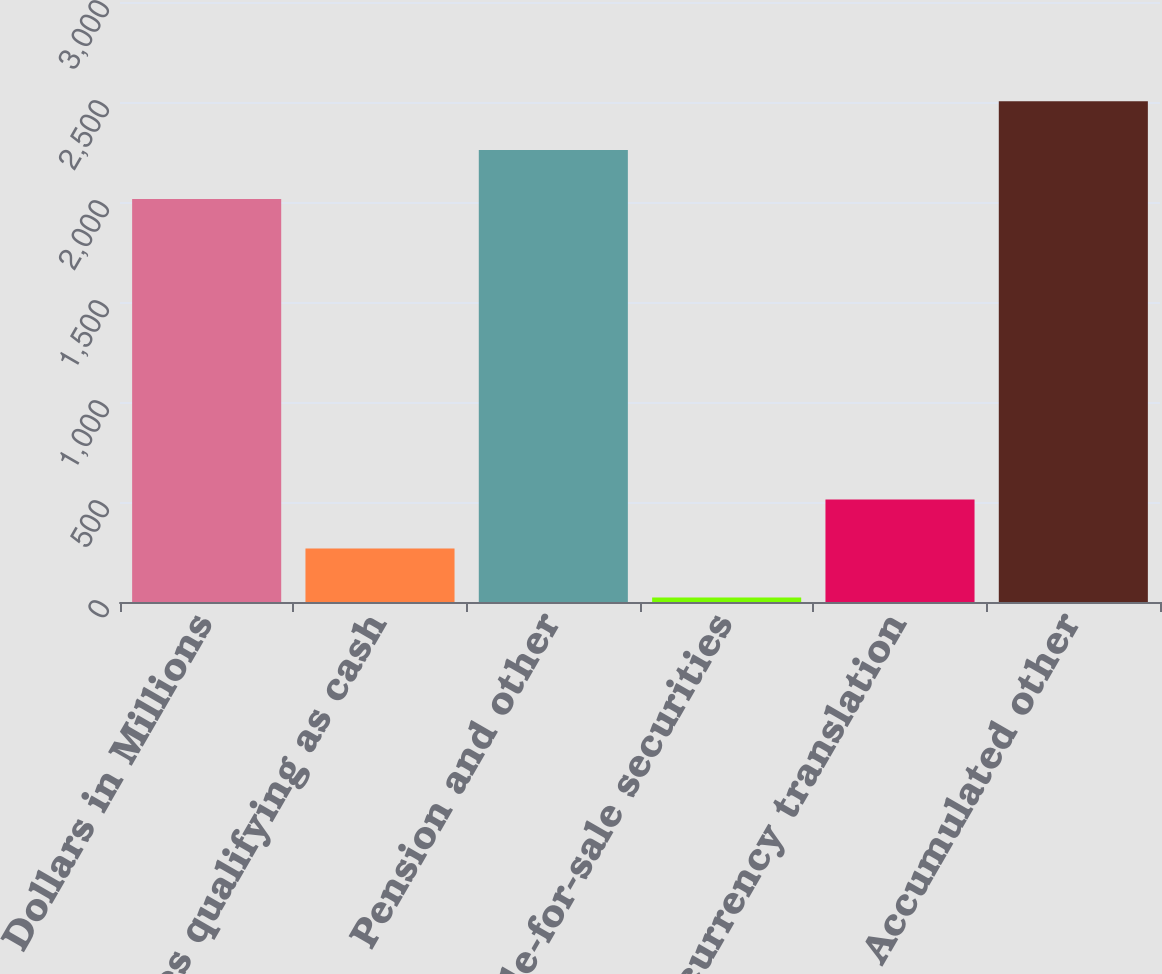<chart> <loc_0><loc_0><loc_500><loc_500><bar_chart><fcel>Dollars in Millions<fcel>Derivatives qualifying as cash<fcel>Pension and other<fcel>Available-for-sale securities<fcel>Foreign currency translation<fcel>Accumulated other<nl><fcel>2015<fcel>267.5<fcel>2259.5<fcel>23<fcel>512<fcel>2504<nl></chart> 